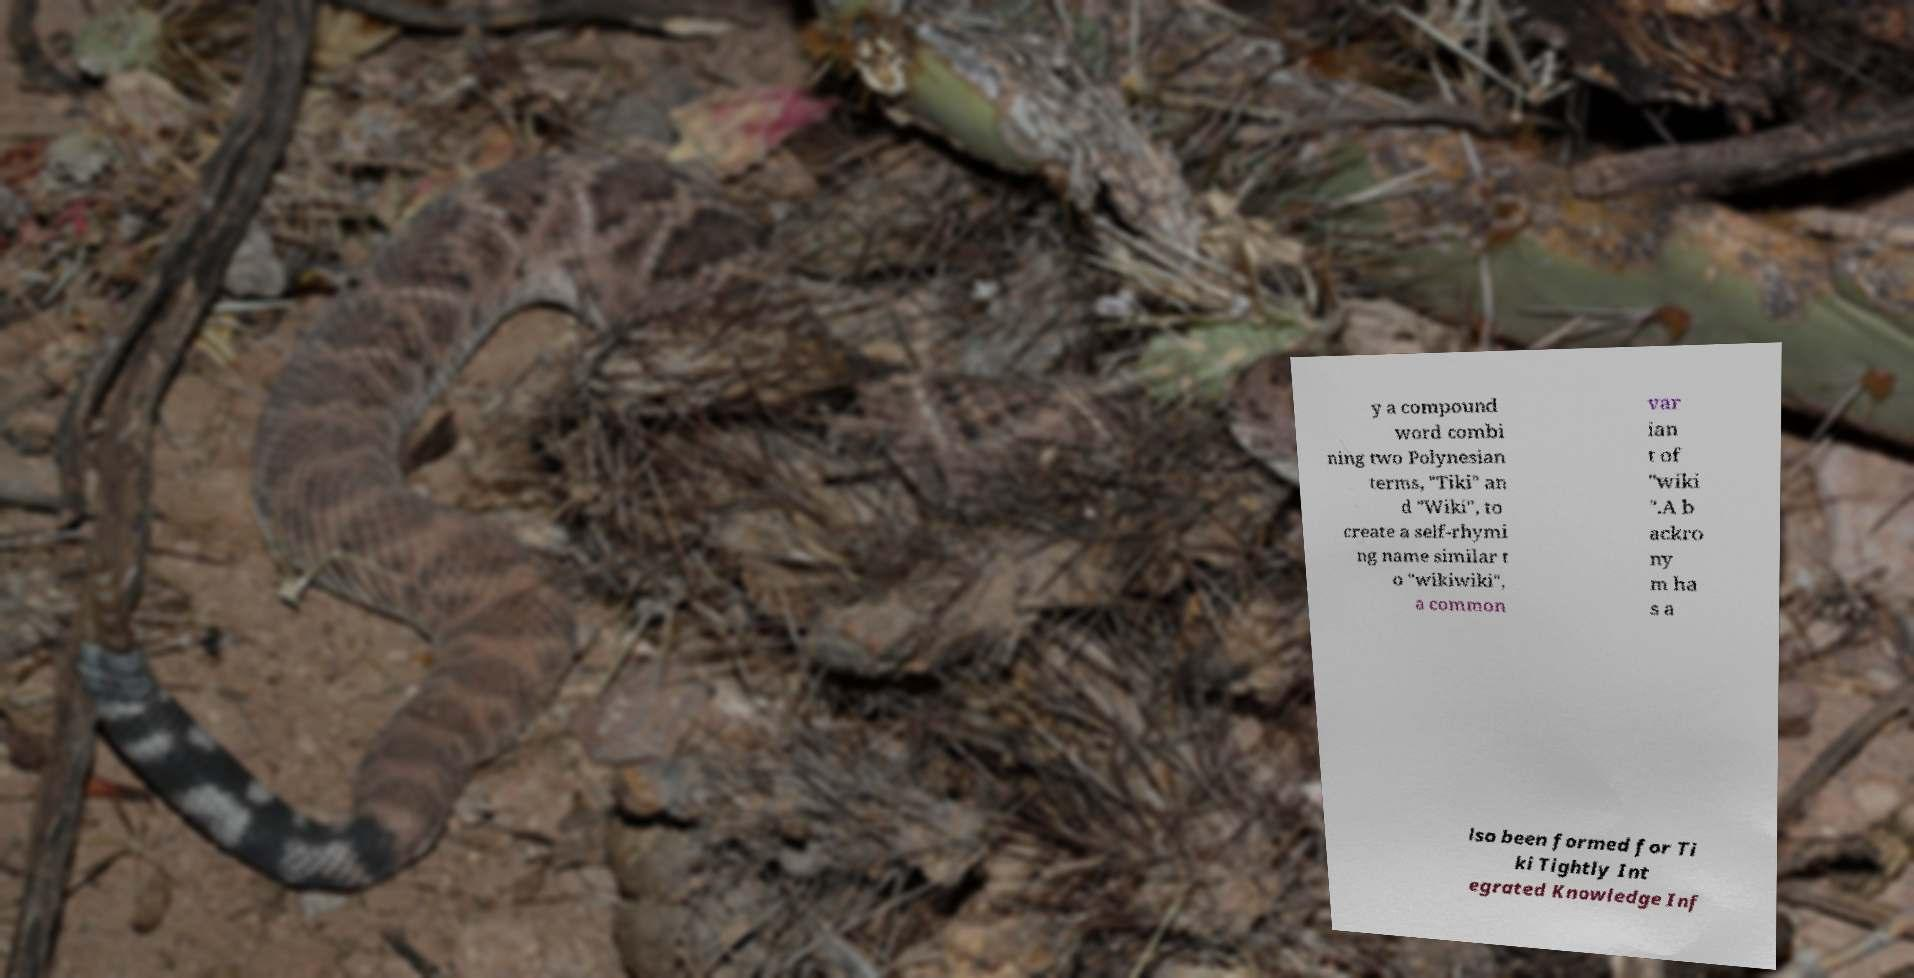Please identify and transcribe the text found in this image. y a compound word combi ning two Polynesian terms, "Tiki" an d "Wiki", to create a self-rhymi ng name similar t o "wikiwiki", a common var ian t of "wiki ".A b ackro ny m ha s a lso been formed for Ti ki Tightly Int egrated Knowledge Inf 